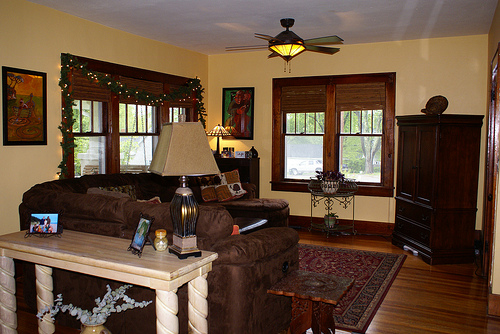How might this room look during a festive holiday like Christmas? Imagine this room transformed into a festive wonderland for Christmas. The windows are adorned with twinkling fairy lights and maybe even a snowy spray. A tall Christmas tree, lavishly decorated with ornaments, ribbons, and a twinkling star at the top, stands proudly in one corner. The smell of pine and cinnamon fills the air, mingling with the aroma of gingerbread cookies baking in the oven. Stockings hang over any available ledge, perhaps beside a crackling fireplace. The table is covered with a festive cloth, featuring a centerpiece of holly and red candles. Gifts wrapped in colorful paper and ribbons are scattered around the room, creating an atmosphere of anticipation and joy. Can you envision a fantastical event taking place in this room? Certainly! Picture a fantastical tea party hosted by an eclectic fairy queen. The furniture is magically alive, with the couches softly purring as they’re sat on and the table gracefully bowing to each guest. The lamps have turned into whimsical creatures with wings, casting gentle, undulating light across the room. The floral arrangement speaks in gentle whispers, recounting tales of far-off lands. The paint in the room shifts colors in tune with the music playing from a mysterious, unseen orchestra. The windows, now portals, reveal enchanted forests and sparkling rivers, allowing snippets of magical creatures to peek through and wave. It's an enchanting evening where reality and magic intertwine seamlessly. 